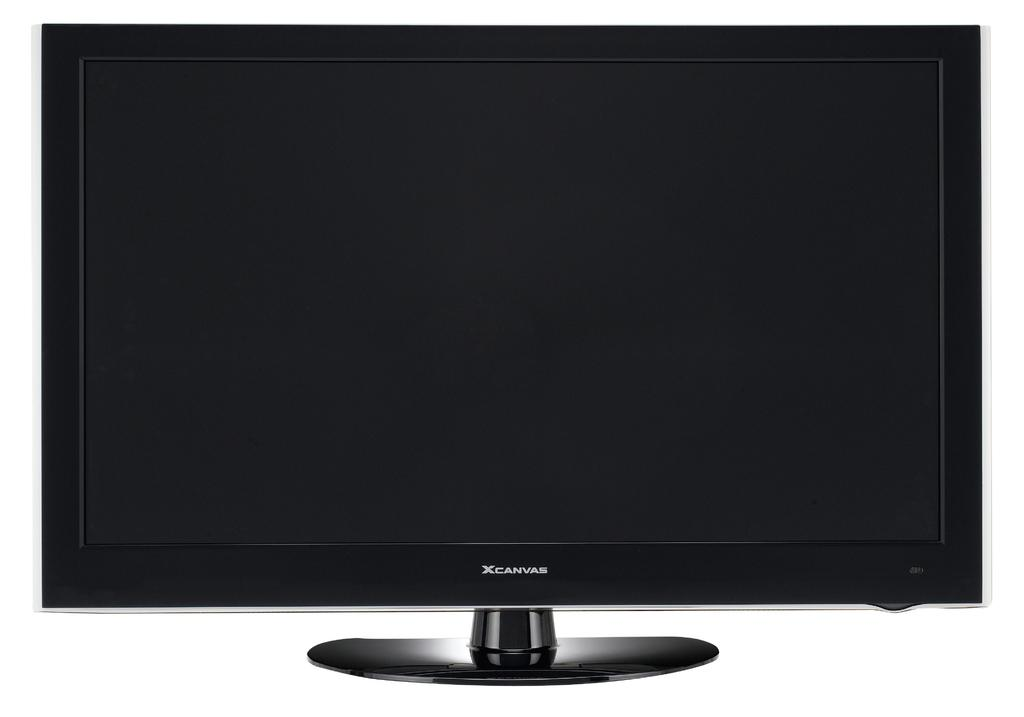Provide a one-sentence caption for the provided image. A computer monitor that says Xcanvas on the bottom. 